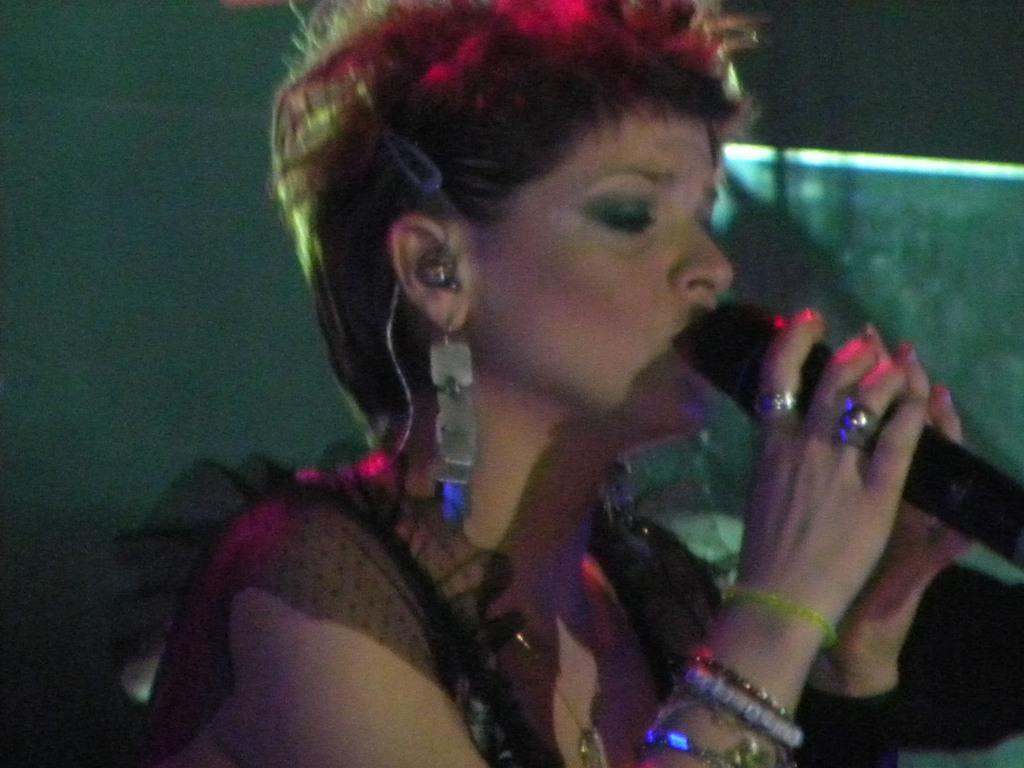Describe this image in one or two sentences. In this image there is a lady holding a mike in her hand, in the background there is a wall. 